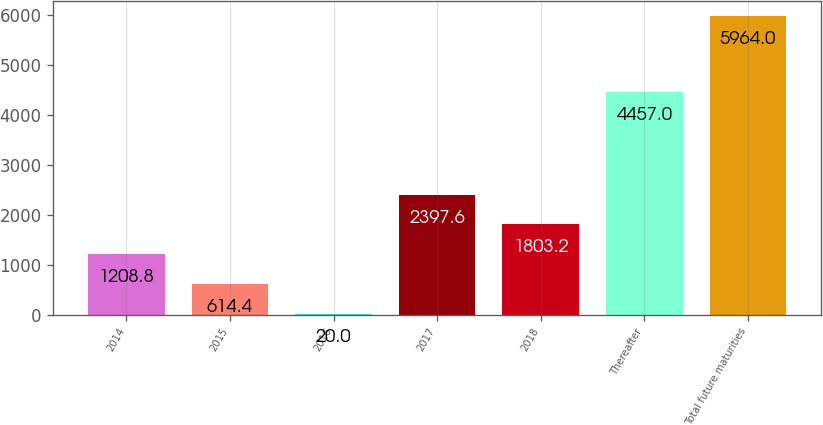<chart> <loc_0><loc_0><loc_500><loc_500><bar_chart><fcel>2014<fcel>2015<fcel>2016<fcel>2017<fcel>2018<fcel>Thereafter<fcel>Total future maturities<nl><fcel>1208.8<fcel>614.4<fcel>20<fcel>2397.6<fcel>1803.2<fcel>4457<fcel>5964<nl></chart> 